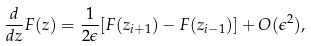<formula> <loc_0><loc_0><loc_500><loc_500>\frac { d } { d z } F ( z ) = \frac { 1 } { 2 \epsilon } [ F ( z _ { i + 1 } ) - F ( z _ { i - 1 } ) ] + O ( \epsilon ^ { 2 } ) ,</formula> 